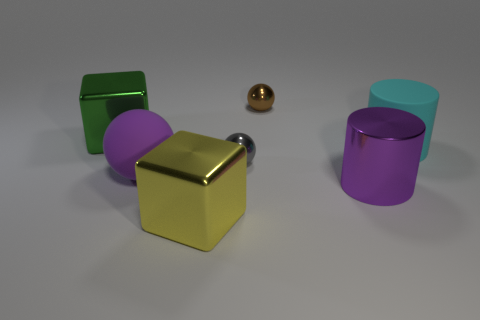There is a large matte object that is behind the gray shiny object; is it the same shape as the big green shiny object?
Ensure brevity in your answer.  No. Are there more big shiny things behind the brown metal thing than blocks?
Keep it short and to the point. No. How many gray things are the same size as the cyan matte cylinder?
Ensure brevity in your answer.  0. What size is the thing that is the same color as the rubber ball?
Your answer should be compact. Large. How many things are green cubes or metallic things that are behind the purple matte thing?
Offer a very short reply. 3. What color is the large object that is both behind the large purple matte object and on the right side of the brown ball?
Keep it short and to the point. Cyan. Does the purple sphere have the same size as the gray shiny thing?
Ensure brevity in your answer.  No. There is a tiny thing on the left side of the small brown thing; what color is it?
Provide a succinct answer. Gray. Are there any large metallic blocks that have the same color as the metallic cylinder?
Provide a succinct answer. No. There is a shiny cylinder that is the same size as the purple rubber object; what color is it?
Ensure brevity in your answer.  Purple. 